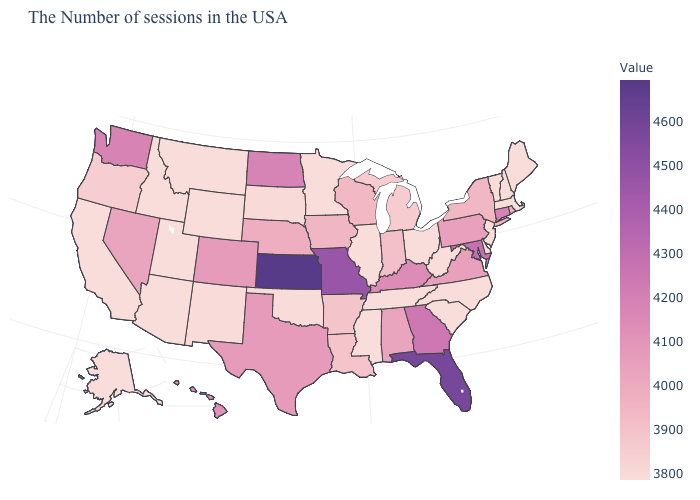Does Ohio have a lower value than Alabama?
Quick response, please. Yes. Does Vermont have the lowest value in the USA?
Answer briefly. Yes. Which states have the highest value in the USA?
Concise answer only. Kansas. Among the states that border Ohio , does West Virginia have the lowest value?
Be succinct. Yes. Does North Dakota have the lowest value in the MidWest?
Be succinct. No. Is the legend a continuous bar?
Concise answer only. Yes. 